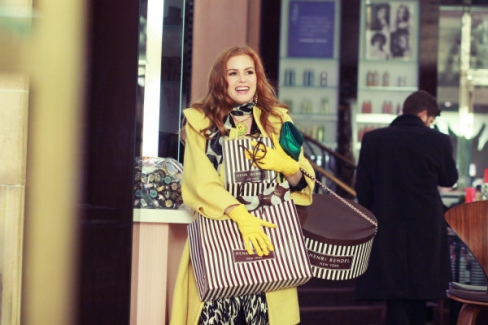What do you think is going on in this snapshot? The image captures a cheerful moment as a woman, dressed in a bright yellow coat, steps out of a shop. She is carrying several bags, suggesting that she has been shopping. The store behind her features a striped awning and appears to sell colorful scarves, shown through its glass display. The background shows a bustling city vibe, with other pedestrians blurred in motion, emphasizing the main subject's vivid attire and happy demeanor as she possibly enjoys a day out shopping in an urban setting. 